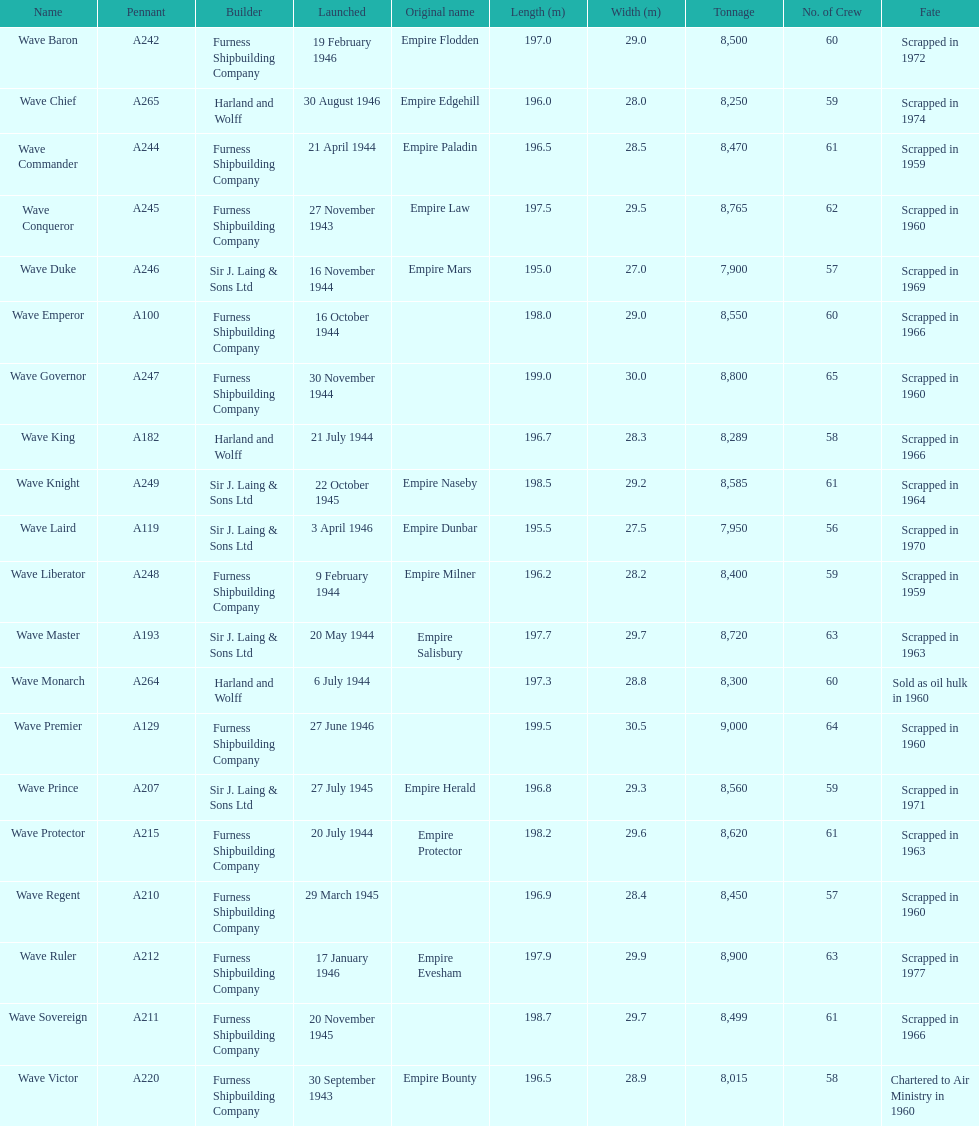Following the wave emperor, which wave-class oiler came next? Wave Duke. 